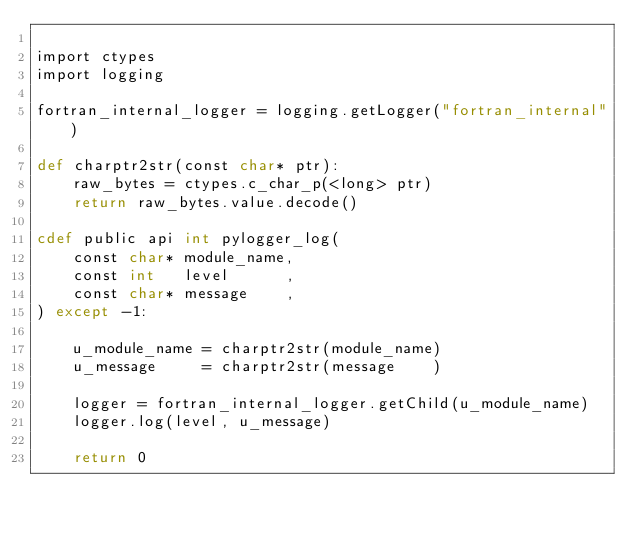Convert code to text. <code><loc_0><loc_0><loc_500><loc_500><_Cython_>
import ctypes
import logging

fortran_internal_logger = logging.getLogger("fortran_internal")

def charptr2str(const char* ptr):
    raw_bytes = ctypes.c_char_p(<long> ptr)
    return raw_bytes.value.decode()

cdef public api int pylogger_log(
    const char* module_name,
    const int   level      ,
    const char* message    ,
) except -1:

    u_module_name = charptr2str(module_name)
    u_message     = charptr2str(message    )

    logger = fortran_internal_logger.getChild(u_module_name)
    logger.log(level, u_message)

    return 0
</code> 